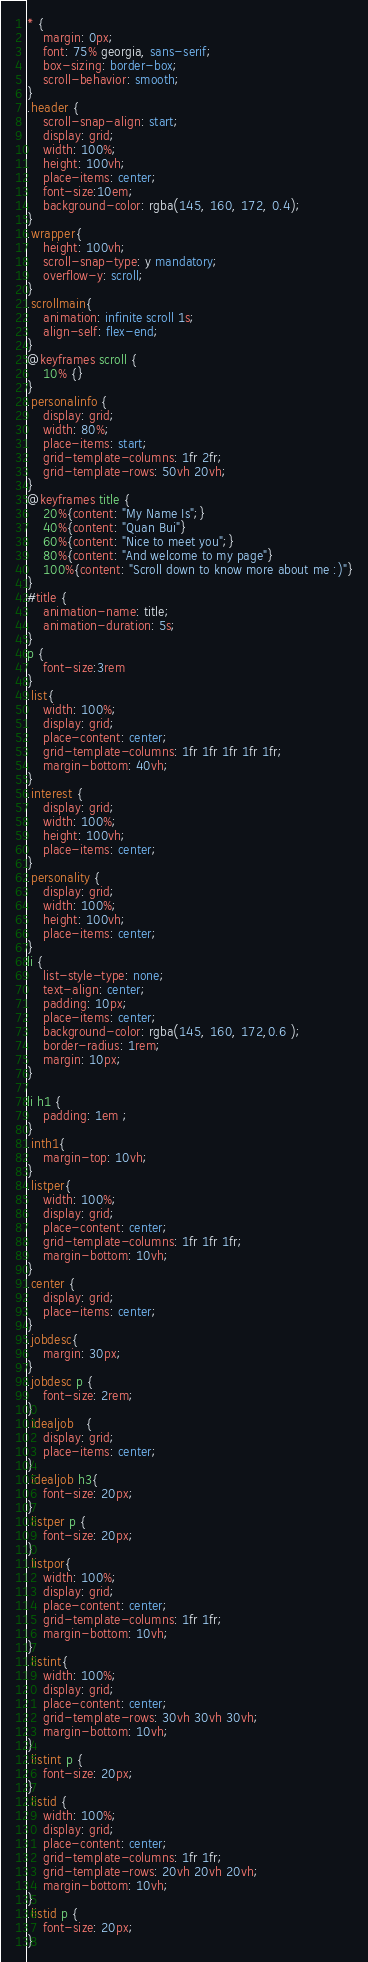<code> <loc_0><loc_0><loc_500><loc_500><_CSS_>* {
    margin: 0px;
    font: 75% georgia, sans-serif;
    box-sizing: border-box;
    scroll-behavior: smooth;
}
.header {
    scroll-snap-align: start;
    display: grid;
    width: 100%;
    height: 100vh;
    place-items: center;
    font-size:10em;
    background-color: rgba(145, 160, 172, 0.4);
}
.wrapper{
    height: 100vh;
    scroll-snap-type: y mandatory;
    overflow-y: scroll;
}
.scrollmain{
    animation: infinite scroll 1s;
    align-self: flex-end;
}
@keyframes scroll {
    10% {}
}
.personalinfo {
    display: grid;
    width: 80%;
    place-items: start;
    grid-template-columns: 1fr 2fr;
    grid-template-rows: 50vh 20vh;
}
@keyframes title {
    20%{content: "My Name Is";}
    40%{content: "Quan Bui"}
    60%{content: "Nice to meet you";}
    80%{content: "And welcome to my page"}
    100%{content: "Scroll down to know more about me :)"}
}
#title {
    animation-name: title;
    animation-duration: 5s;
}
p {
    font-size:3rem
}
.list{
    width: 100%;
    display: grid;
    place-content: center;
    grid-template-columns: 1fr 1fr 1fr 1fr 1fr;
    margin-bottom: 40vh;
}
.interest {
    display: grid;
    width: 100%;
    height: 100vh;
    place-items: center;
}
.personality {
    display: grid;
    width: 100%;
    height: 100vh;
    place-items: center;
}
li {
    list-style-type: none;
    text-align: center;
    padding: 10px;
    place-items: center;
    background-color: rgba(145, 160, 172,0.6 );
    border-radius: 1rem;
    margin: 10px;
}

li h1 {
    padding: 1em ;
}
.inth1{
    margin-top: 10vh;
}
.listper{
    width: 100%;
    display: grid;
    place-content: center;
    grid-template-columns: 1fr 1fr 1fr;
    margin-bottom: 10vh;
}   
.center {
    display: grid;
    place-items: center;
}
.jobdesc{
    margin: 30px;
}
.jobdesc p {
    font-size: 2rem;
}
.idealjob   {
    display: grid;
    place-items: center;
}
.idealjob h3{
    font-size: 20px;
}
.listper p {
    font-size: 20px;
}
.listpor{
    width: 100%;
    display: grid;
    place-content: center;
    grid-template-columns: 1fr 1fr;
    margin-bottom: 10vh;
} 
.listint{
    width: 100%;
    display: grid;
    place-content: center;
    grid-template-rows: 30vh 30vh 30vh;
    margin-bottom: 10vh;
} 
.listint p {
    font-size: 20px;
}
.listid {
    width: 100%;
    display: grid;
    place-content: center;
    grid-template-columns: 1fr 1fr;
    grid-template-rows: 20vh 20vh 20vh;
    margin-bottom: 10vh;
}
.listid p {
    font-size: 20px;
}
</code> 